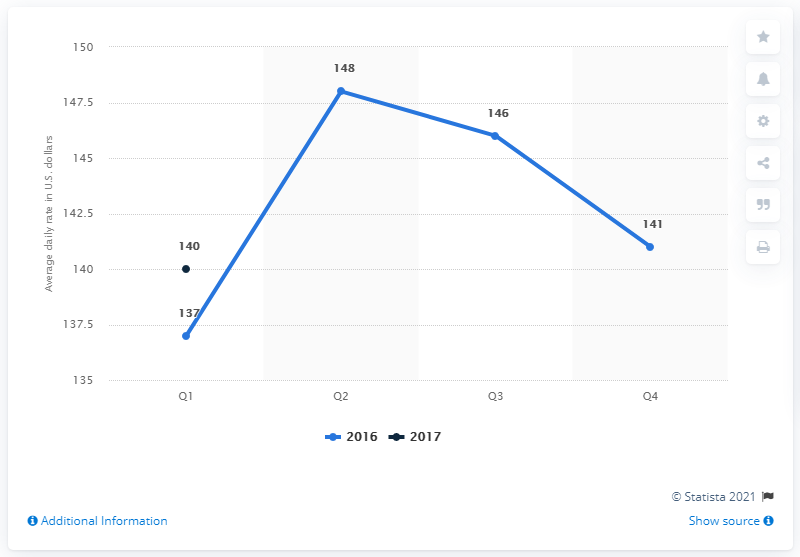List a handful of essential elements in this visual. In 2016, the quarter with the highest average daily rate was the second quarter, or Q2. In the first quarter of 2017, the average daily rate of hotels in St. Louis, United States was 140 dollars. The average in 2016 is 143. 